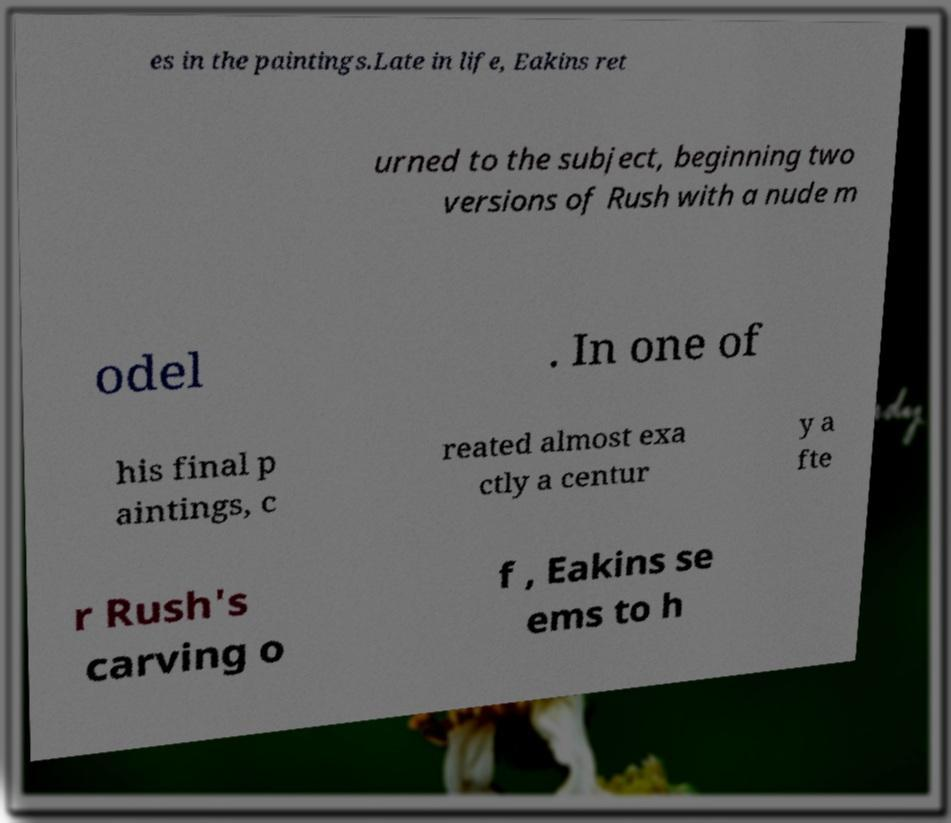Please read and relay the text visible in this image. What does it say? es in the paintings.Late in life, Eakins ret urned to the subject, beginning two versions of Rush with a nude m odel . In one of his final p aintings, c reated almost exa ctly a centur y a fte r Rush's carving o f , Eakins se ems to h 